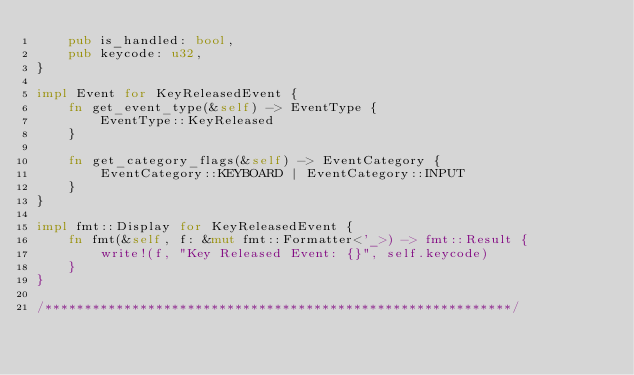Convert code to text. <code><loc_0><loc_0><loc_500><loc_500><_Rust_>    pub is_handled: bool,
    pub keycode: u32,
}

impl Event for KeyReleasedEvent {
    fn get_event_type(&self) -> EventType {
        EventType::KeyReleased
    }

    fn get_category_flags(&self) -> EventCategory {
        EventCategory::KEYBOARD | EventCategory::INPUT
    }
}

impl fmt::Display for KeyReleasedEvent {
    fn fmt(&self, f: &mut fmt::Formatter<'_>) -> fmt::Result {
        write!(f, "Key Released Event: {}", self.keycode)
    }
}

/***********************************************************/
</code> 